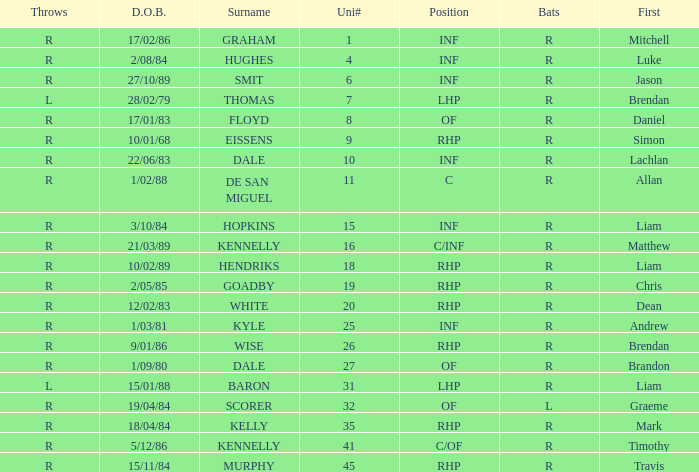Which batter has the last name Graham? R. I'm looking to parse the entire table for insights. Could you assist me with that? {'header': ['Throws', 'D.O.B.', 'Surname', 'Uni#', 'Position', 'Bats', 'First'], 'rows': [['R', '17/02/86', 'GRAHAM', '1', 'INF', 'R', 'Mitchell'], ['R', '2/08/84', 'HUGHES', '4', 'INF', 'R', 'Luke'], ['R', '27/10/89', 'SMIT', '6', 'INF', 'R', 'Jason'], ['L', '28/02/79', 'THOMAS', '7', 'LHP', 'R', 'Brendan'], ['R', '17/01/83', 'FLOYD', '8', 'OF', 'R', 'Daniel'], ['R', '10/01/68', 'EISSENS', '9', 'RHP', 'R', 'Simon'], ['R', '22/06/83', 'DALE', '10', 'INF', 'R', 'Lachlan'], ['R', '1/02/88', 'DE SAN MIGUEL', '11', 'C', 'R', 'Allan'], ['R', '3/10/84', 'HOPKINS', '15', 'INF', 'R', 'Liam'], ['R', '21/03/89', 'KENNELLY', '16', 'C/INF', 'R', 'Matthew'], ['R', '10/02/89', 'HENDRIKS', '18', 'RHP', 'R', 'Liam'], ['R', '2/05/85', 'GOADBY', '19', 'RHP', 'R', 'Chris'], ['R', '12/02/83', 'WHITE', '20', 'RHP', 'R', 'Dean'], ['R', '1/03/81', 'KYLE', '25', 'INF', 'R', 'Andrew'], ['R', '9/01/86', 'WISE', '26', 'RHP', 'R', 'Brendan'], ['R', '1/09/80', 'DALE', '27', 'OF', 'R', 'Brandon'], ['L', '15/01/88', 'BARON', '31', 'LHP', 'R', 'Liam'], ['R', '19/04/84', 'SCORER', '32', 'OF', 'L', 'Graeme'], ['R', '18/04/84', 'KELLY', '35', 'RHP', 'R', 'Mark'], ['R', '5/12/86', 'KENNELLY', '41', 'C/OF', 'R', 'Timothy'], ['R', '15/11/84', 'MURPHY', '45', 'RHP', 'R', 'Travis']]} 